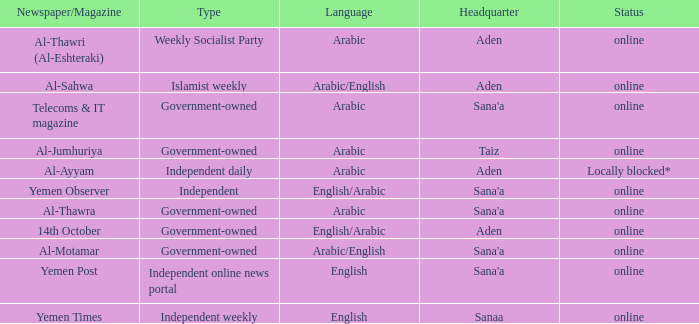What is Headquarter, when Type is Independent Online News Portal? Sana'a. 